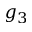<formula> <loc_0><loc_0><loc_500><loc_500>g _ { 3 }</formula> 